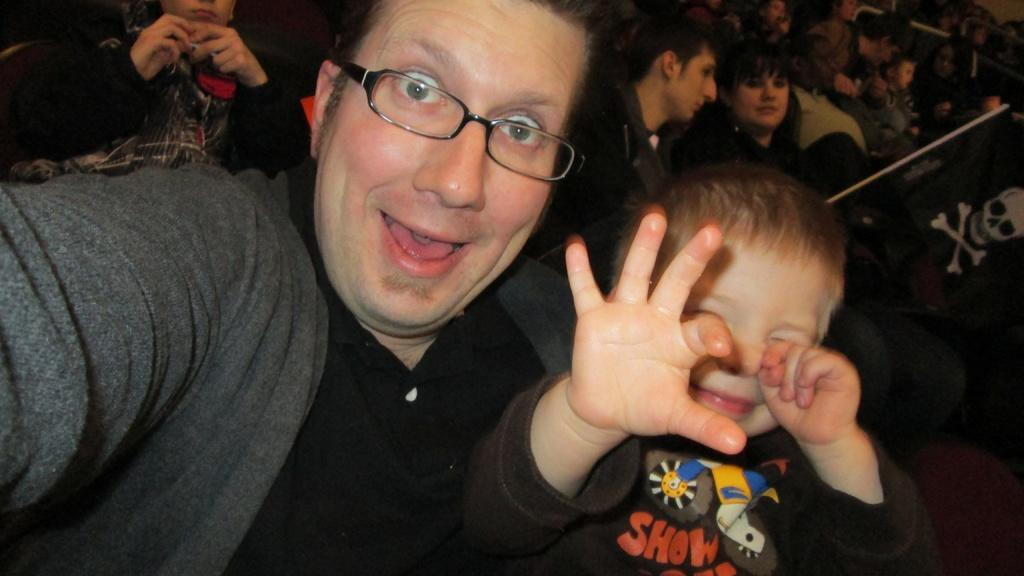Who is present in the image? There is a man and a boy in the image. What are the expressions on their faces? Both the man and the boy are smiling. What can be seen in the background of the image? There is a group of people sitting in the background of the image. What object is hanging from a pole in the image? There is a cloth hanging from a pole in the image. What type of berry is being distributed by the man in the image? There is no berry present in the image, nor is there any indication of distribution or the man handing out anything. 